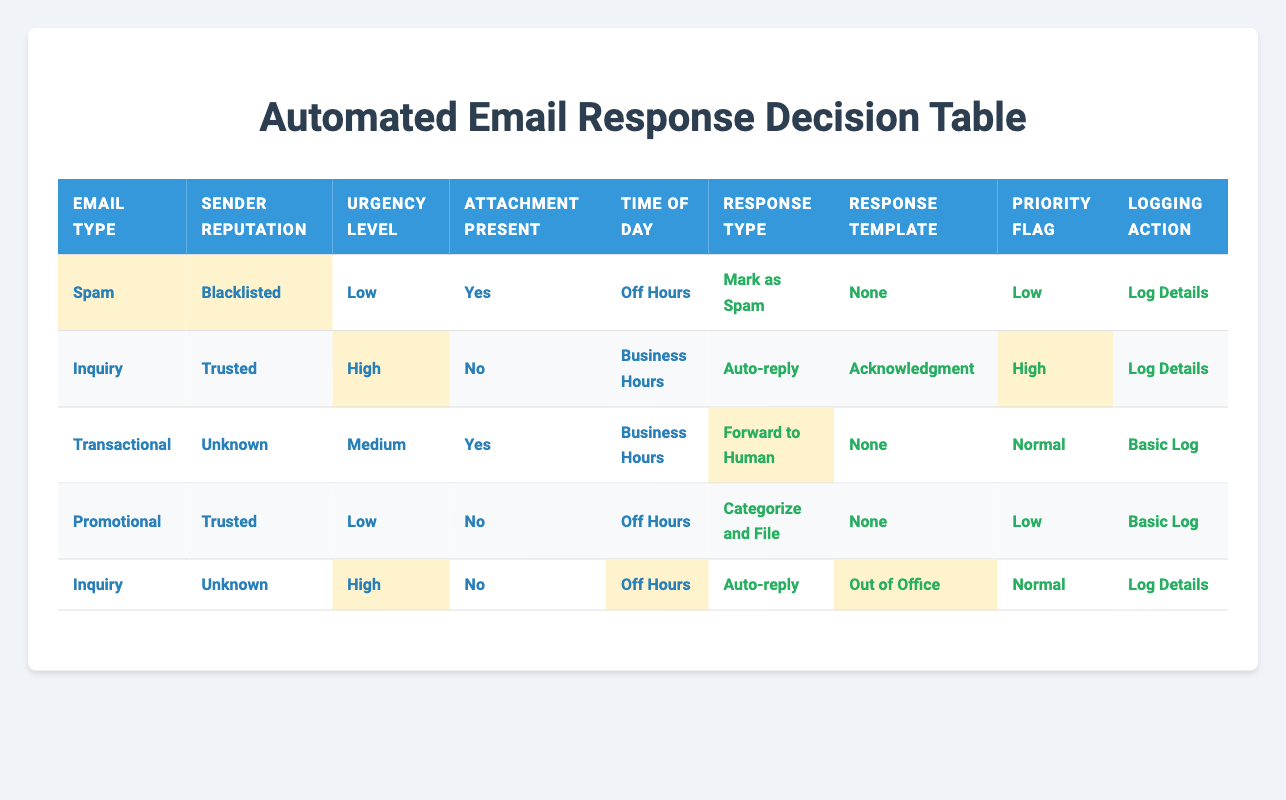What is the response type for inquiry emails from trusted senders during business hours? According to the table, when the email type is "Inquiry", sender reputation is "Trusted", and it is during "Business Hours", the response type is "Auto-reply".
Answer: Auto-reply How many unique response types are listed in the table? The response types listed in the table are: "Auto-reply", "Forward to Human", "Mark as Spam", "Delete", and "Categorize and File". This results in a total of 5 unique response types.
Answer: 5 Is there any email category that has a "Spam" response template? The table indicates that the only email type with a "Spam Warning" response template is "Mark as Spam". There are no entries specifically labeled with "Spam" as a response template.
Answer: No For transactional emails with unknown sender reputation and medium urgency, what actions are taken? The corresponding row shows that for transactional emails where the sender is "Unknown" and urgency level is "Medium", the actions taken are: "Forward to Human", "None" for the response template, "Normal" for the priority flag, and "Basic Log" for the logging action.
Answer: Forward to Human, None, Normal, Basic Log What is the priority flag for promotional emails from trusted senders during off hours? In the table, it shows that promotional emails from trusted senders during off hours have a priority flag of "Low".
Answer: Low What is the most common response type for high urgency inquiries? By examining the rows, there are two entries for inquiries classified as high urgency: one from a trusted sender leading to "Auto-reply" (Acknowledgment) and one from an unknown sender leading to "Auto-reply" (Out of Office). Thus, the most common response type for high urgency inquiries is "Auto-reply".
Answer: Auto-reply In total, how many entries in the table have logging actions categorized as "Log Details"? There are two entries in the table that include "Log Details" as the logging action, specifically for the inquiry emails both trusted and unknown during business hours and off hours.
Answer: 2 What is the relationship between the time of day and the response type for inquiries? Analyzing the entries, inquiries during "Business Hours" receive an "Auto-reply" (Acknowledgment), while those during "Off Hours" receive an "Auto-reply" (Out of Office). Thus, inquiries get an auto-reply in both scenarios based on the time of day.
Answer: Both lead to Auto-reply What is the action when a spam email is received from a blacklisted sender with a low urgency? For spam emails from blacklisted senders with low urgency, the action taken is to "Mark as Spam", and no specific response template is used. The priority flag is low, and the logging action is to log details.
Answer: Mark as Spam 